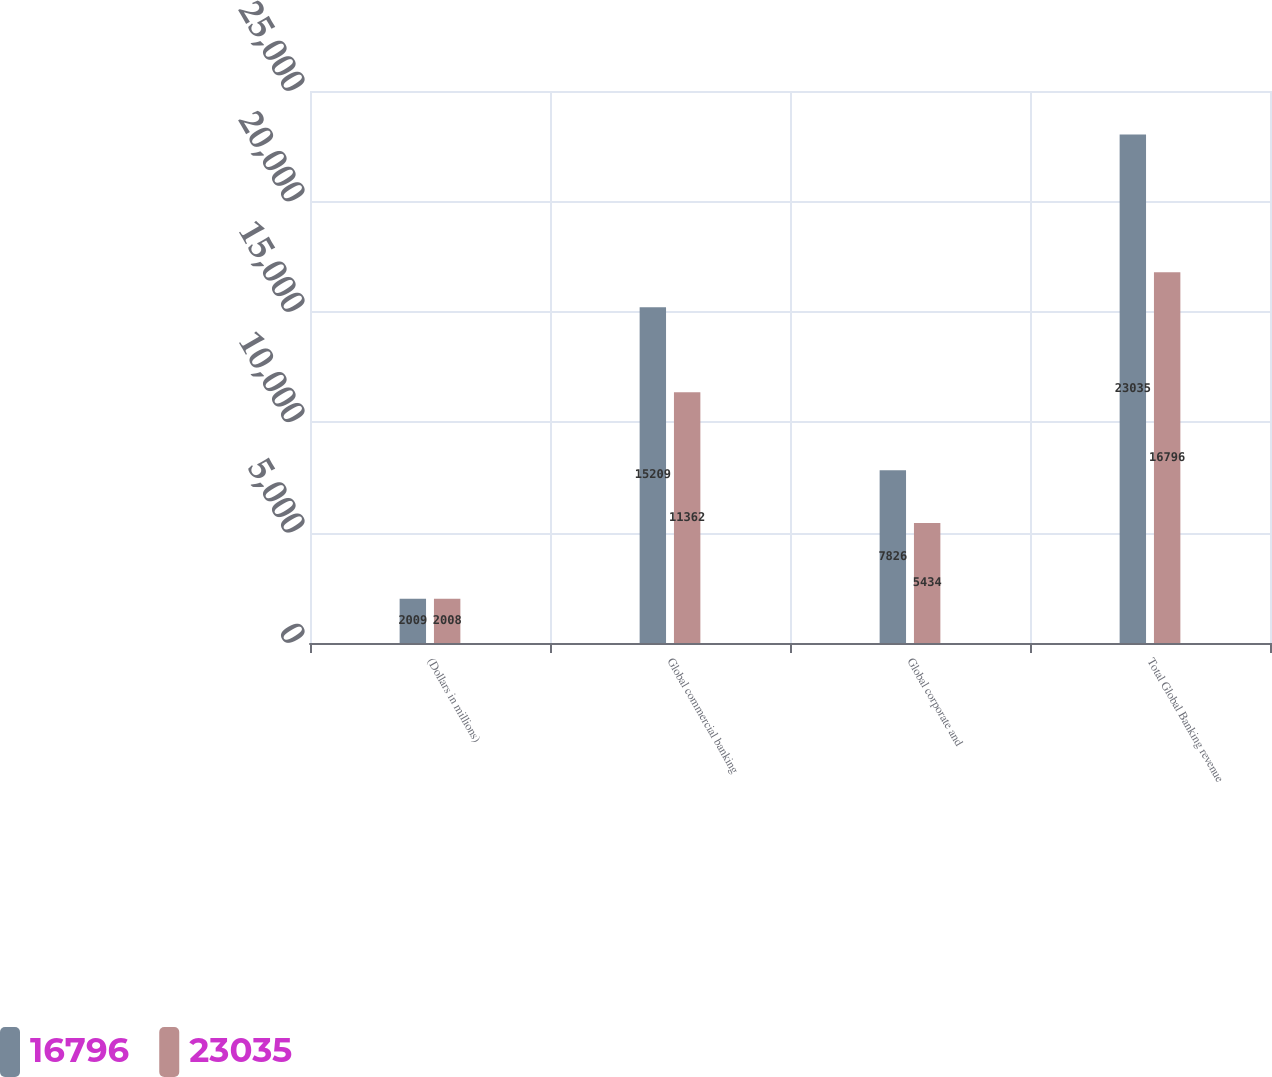Convert chart. <chart><loc_0><loc_0><loc_500><loc_500><stacked_bar_chart><ecel><fcel>(Dollars in millions)<fcel>Global commercial banking<fcel>Global corporate and<fcel>Total Global Banking revenue<nl><fcel>16796<fcel>2009<fcel>15209<fcel>7826<fcel>23035<nl><fcel>23035<fcel>2008<fcel>11362<fcel>5434<fcel>16796<nl></chart> 